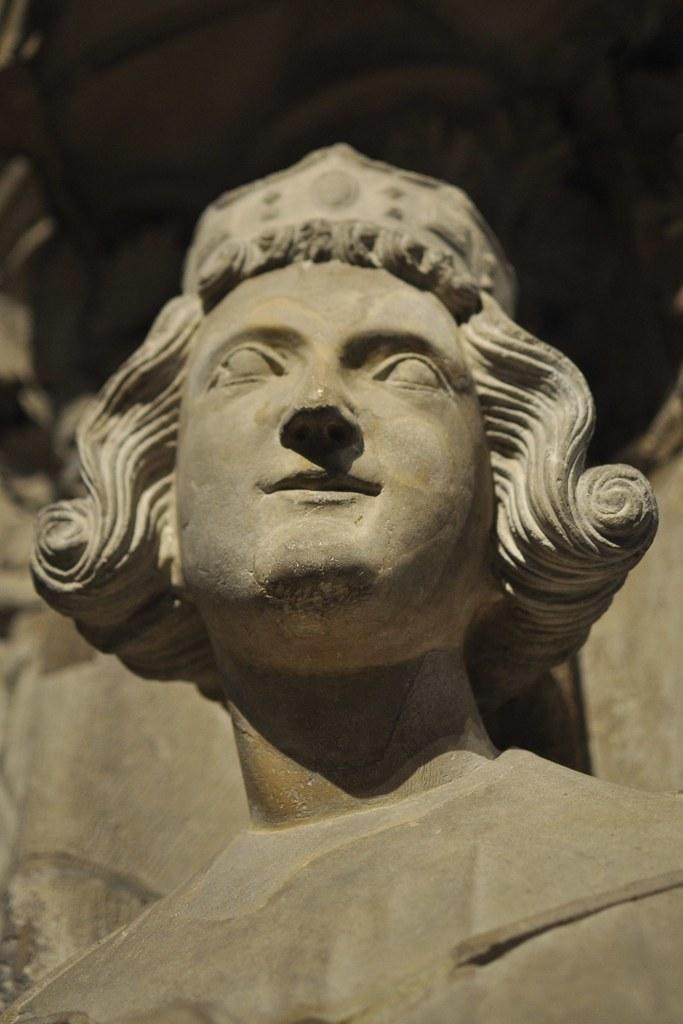What is the main subject of the image? There is a sculpture on a stone in the image. Can you describe the setting of the image? There is a wall in the background of the image. What type of scent can be detected from the sofa in the image? There is no sofa present in the image, so it is not possible to detect any scent from it. 